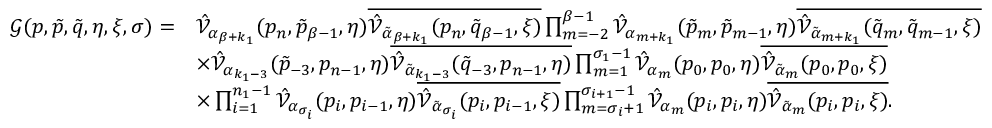<formula> <loc_0><loc_0><loc_500><loc_500>\begin{array} { r l } { \mathcal { G } ( p , \tilde { p } , \tilde { q } , \eta , \xi , \sigma ) = } & { \hat { \mathcal { V } } _ { \alpha _ { \beta + k _ { 1 } } } ( p _ { n } , \tilde { p } _ { \beta - 1 } , \eta ) \overline { { \hat { \mathcal { V } } _ { \tilde { \alpha } _ { \beta + k _ { 1 } } } ( p _ { n } , \tilde { q } _ { \beta - 1 } , \xi ) } } \prod _ { m = - 2 } ^ { \beta - 1 } \hat { \mathcal { V } } _ { \alpha _ { m + k _ { 1 } } } ( \tilde { p } _ { m } , \tilde { p } _ { m - 1 } , \eta ) \overline { { \hat { \mathcal { V } } _ { \tilde { \alpha } _ { m + k _ { 1 } } } ( \tilde { q } _ { m } , \tilde { q } _ { m - 1 } , \xi ) } } } \\ & { \times \hat { \mathcal { V } } _ { \alpha _ { k _ { 1 } - 3 } } ( \tilde { p } _ { - 3 } , p _ { n - 1 } , \eta ) \overline { { \hat { \mathcal { V } } _ { \tilde { \alpha } _ { k _ { 1 } - 3 } } ( \tilde { q } _ { - 3 } , p _ { n - 1 } , \eta ) } } \prod _ { m = 1 } ^ { \sigma _ { 1 } - 1 } \hat { \mathcal { V } } _ { \alpha _ { m } } ( p _ { 0 } , p _ { 0 } , \eta ) \overline { { \hat { \mathcal { V } } _ { \tilde { \alpha } _ { m } } ( p _ { 0 } , p _ { 0 } , \xi ) } } } \\ & { \times \prod _ { i = 1 } ^ { n _ { 1 } - 1 } \hat { \mathcal { V } } _ { \alpha _ { \sigma _ { i } } } ( p _ { i } , p _ { i - 1 } , \eta ) \overline { { \hat { \mathcal { V } } _ { \tilde { \alpha } _ { \sigma _ { i } } } ( p _ { i } , p _ { i - 1 } , \xi ) } } \prod _ { m = \sigma _ { i } + 1 } ^ { \sigma _ { i + 1 } - 1 } \hat { \mathcal { V } } _ { \alpha _ { m } } ( p _ { i } , p _ { i } , \eta ) \overline { { \hat { \mathcal { V } } _ { \tilde { \alpha } _ { m } } ( p _ { i } , p _ { i } , \xi ) } } . } \end{array}</formula> 